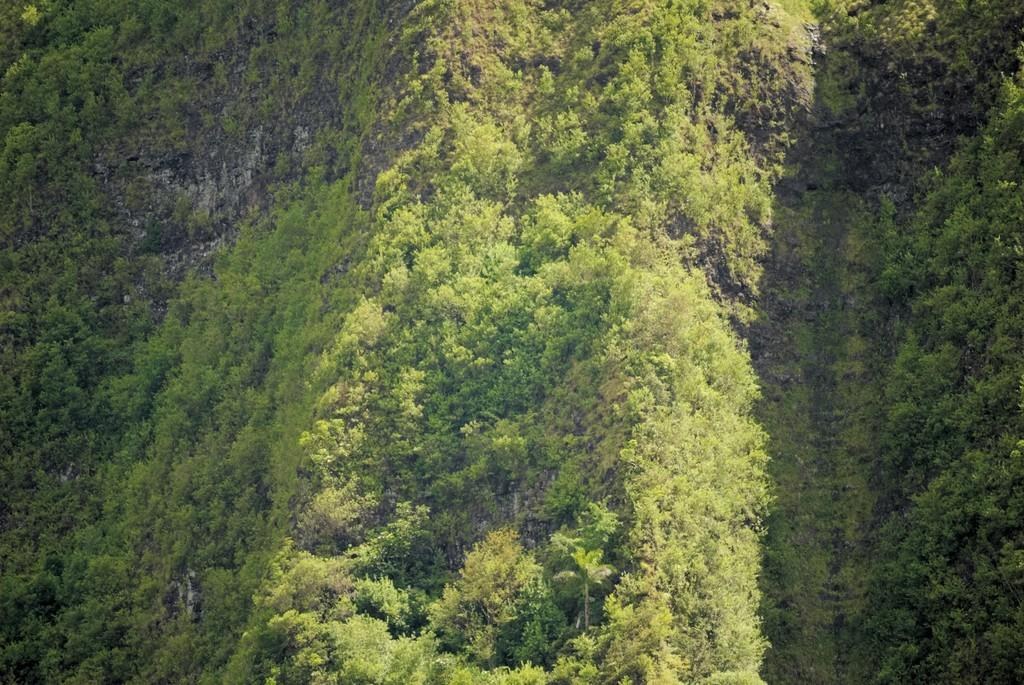What is the primary feature of the image? The primary feature of the image is the presence of many trees. Where are the trees located? The trees are on a mountain. What type of word can be seen growing on the trees in the image? There are no words present in the image; it features trees on a mountain. 